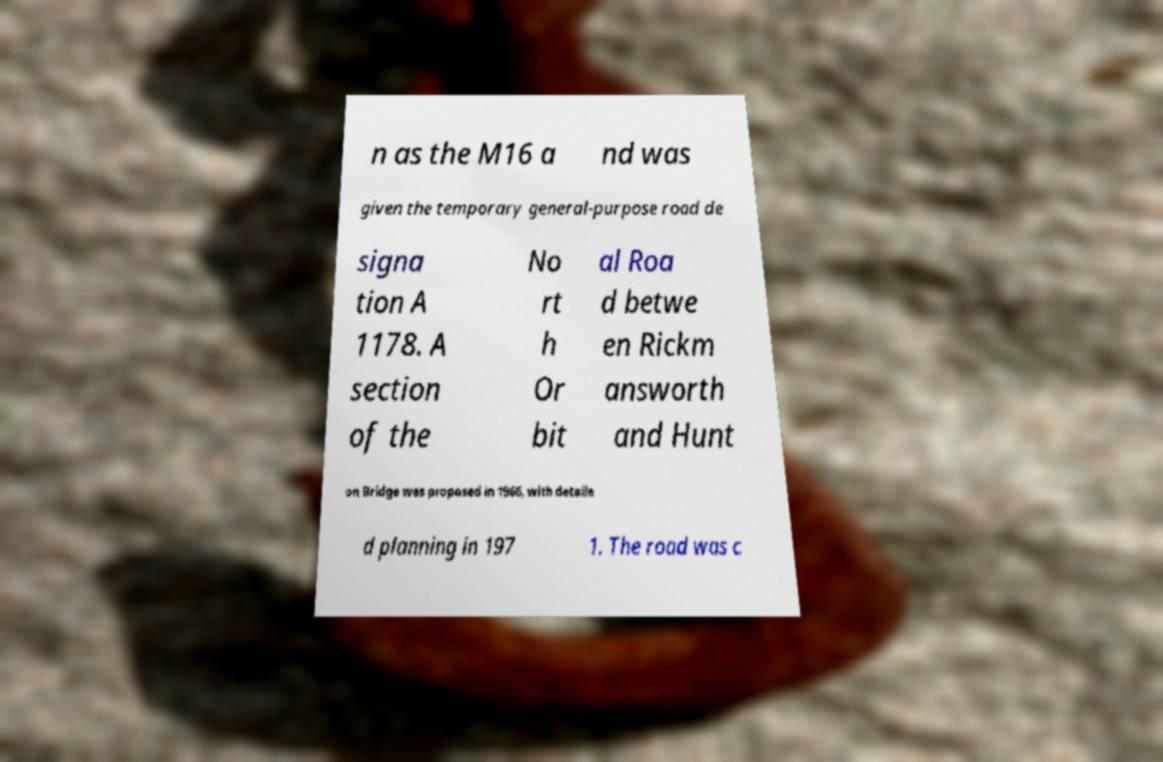Can you accurately transcribe the text from the provided image for me? n as the M16 a nd was given the temporary general-purpose road de signa tion A 1178. A section of the No rt h Or bit al Roa d betwe en Rickm answorth and Hunt on Bridge was proposed in 1966, with detaile d planning in 197 1. The road was c 